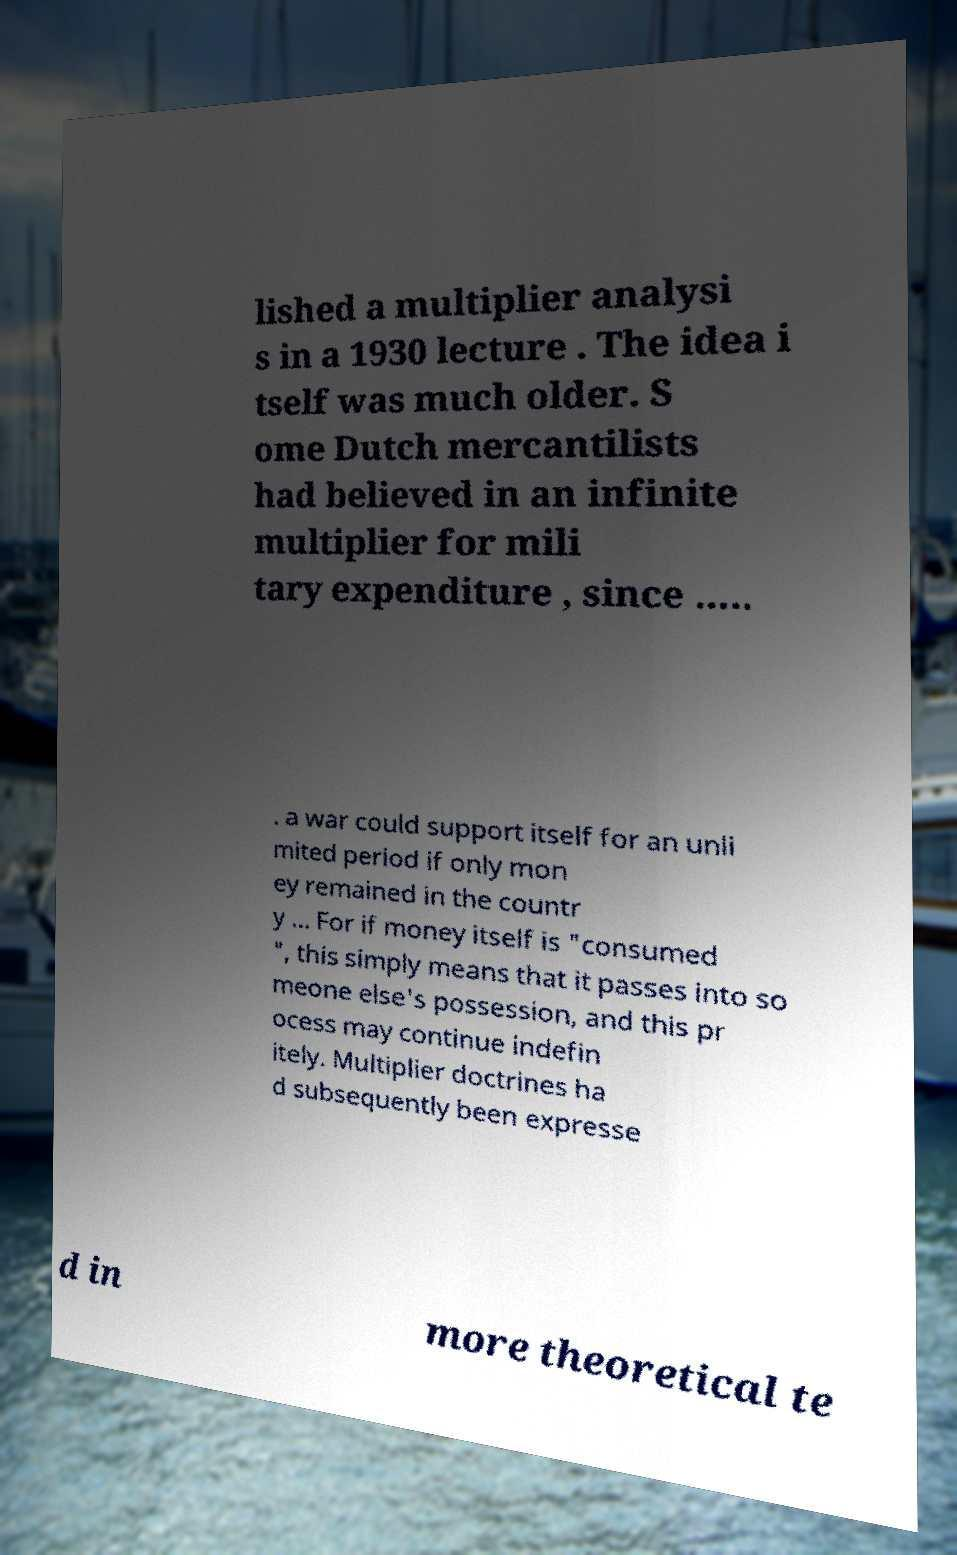I need the written content from this picture converted into text. Can you do that? lished a multiplier analysi s in a 1930 lecture . The idea i tself was much older. S ome Dutch mercantilists had believed in an infinite multiplier for mili tary expenditure , since ..... . a war could support itself for an unli mited period if only mon ey remained in the countr y ... For if money itself is "consumed ", this simply means that it passes into so meone else's possession, and this pr ocess may continue indefin itely. Multiplier doctrines ha d subsequently been expresse d in more theoretical te 